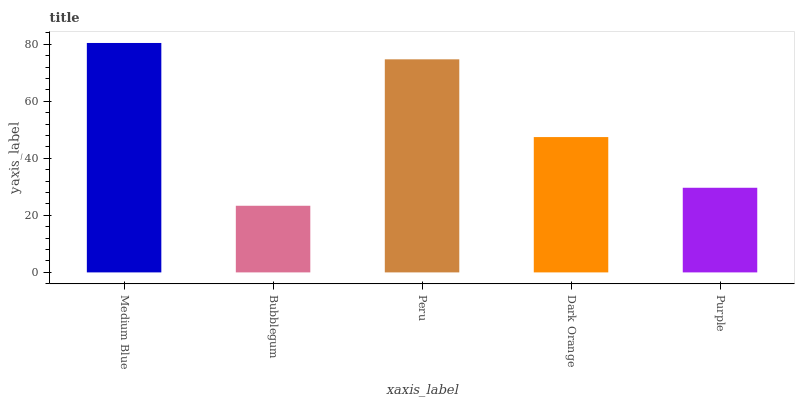Is Bubblegum the minimum?
Answer yes or no. Yes. Is Medium Blue the maximum?
Answer yes or no. Yes. Is Peru the minimum?
Answer yes or no. No. Is Peru the maximum?
Answer yes or no. No. Is Peru greater than Bubblegum?
Answer yes or no. Yes. Is Bubblegum less than Peru?
Answer yes or no. Yes. Is Bubblegum greater than Peru?
Answer yes or no. No. Is Peru less than Bubblegum?
Answer yes or no. No. Is Dark Orange the high median?
Answer yes or no. Yes. Is Dark Orange the low median?
Answer yes or no. Yes. Is Bubblegum the high median?
Answer yes or no. No. Is Bubblegum the low median?
Answer yes or no. No. 